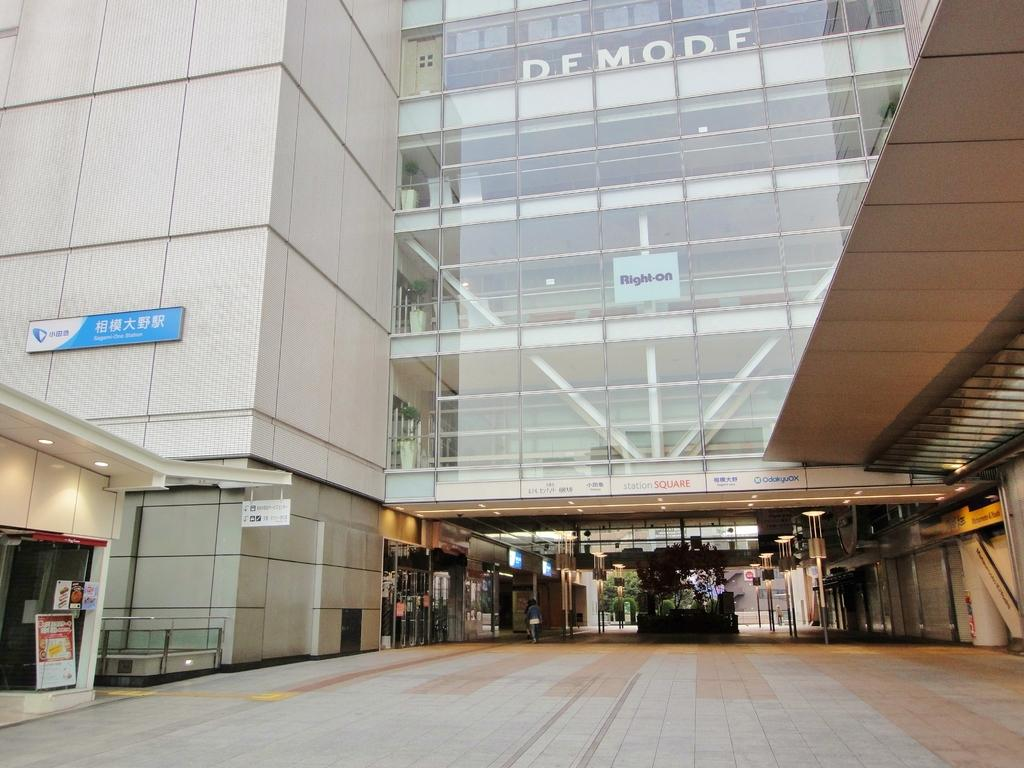What type of structure is present in the image? There is a building with sign boards in the image. Can you describe the person in the image? A person is standing on the ground in the image. What can be seen illuminated in the image? There are lights visible in the image. What type of yarn is being used by the government in the image? There is no mention of yarn or the government in the image, so this question cannot be answered. 